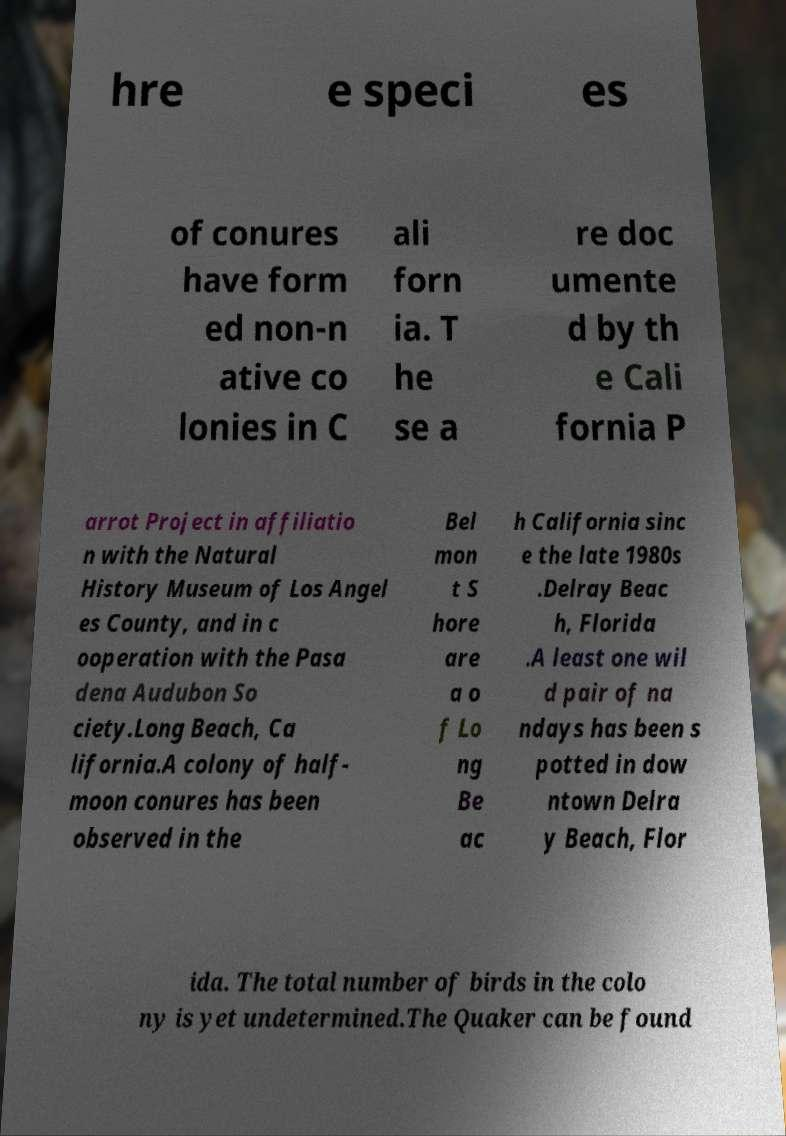Can you read and provide the text displayed in the image?This photo seems to have some interesting text. Can you extract and type it out for me? hre e speci es of conures have form ed non-n ative co lonies in C ali forn ia. T he se a re doc umente d by th e Cali fornia P arrot Project in affiliatio n with the Natural History Museum of Los Angel es County, and in c ooperation with the Pasa dena Audubon So ciety.Long Beach, Ca lifornia.A colony of half- moon conures has been observed in the Bel mon t S hore are a o f Lo ng Be ac h California sinc e the late 1980s .Delray Beac h, Florida .A least one wil d pair of na ndays has been s potted in dow ntown Delra y Beach, Flor ida. The total number of birds in the colo ny is yet undetermined.The Quaker can be found 